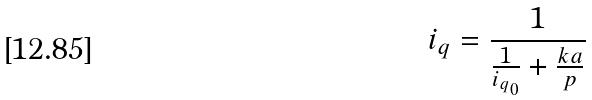Convert formula to latex. <formula><loc_0><loc_0><loc_500><loc_500>i _ { q } = \frac { 1 } { \frac { 1 } { i _ { q _ { 0 } } } + \frac { k a } { p } }</formula> 